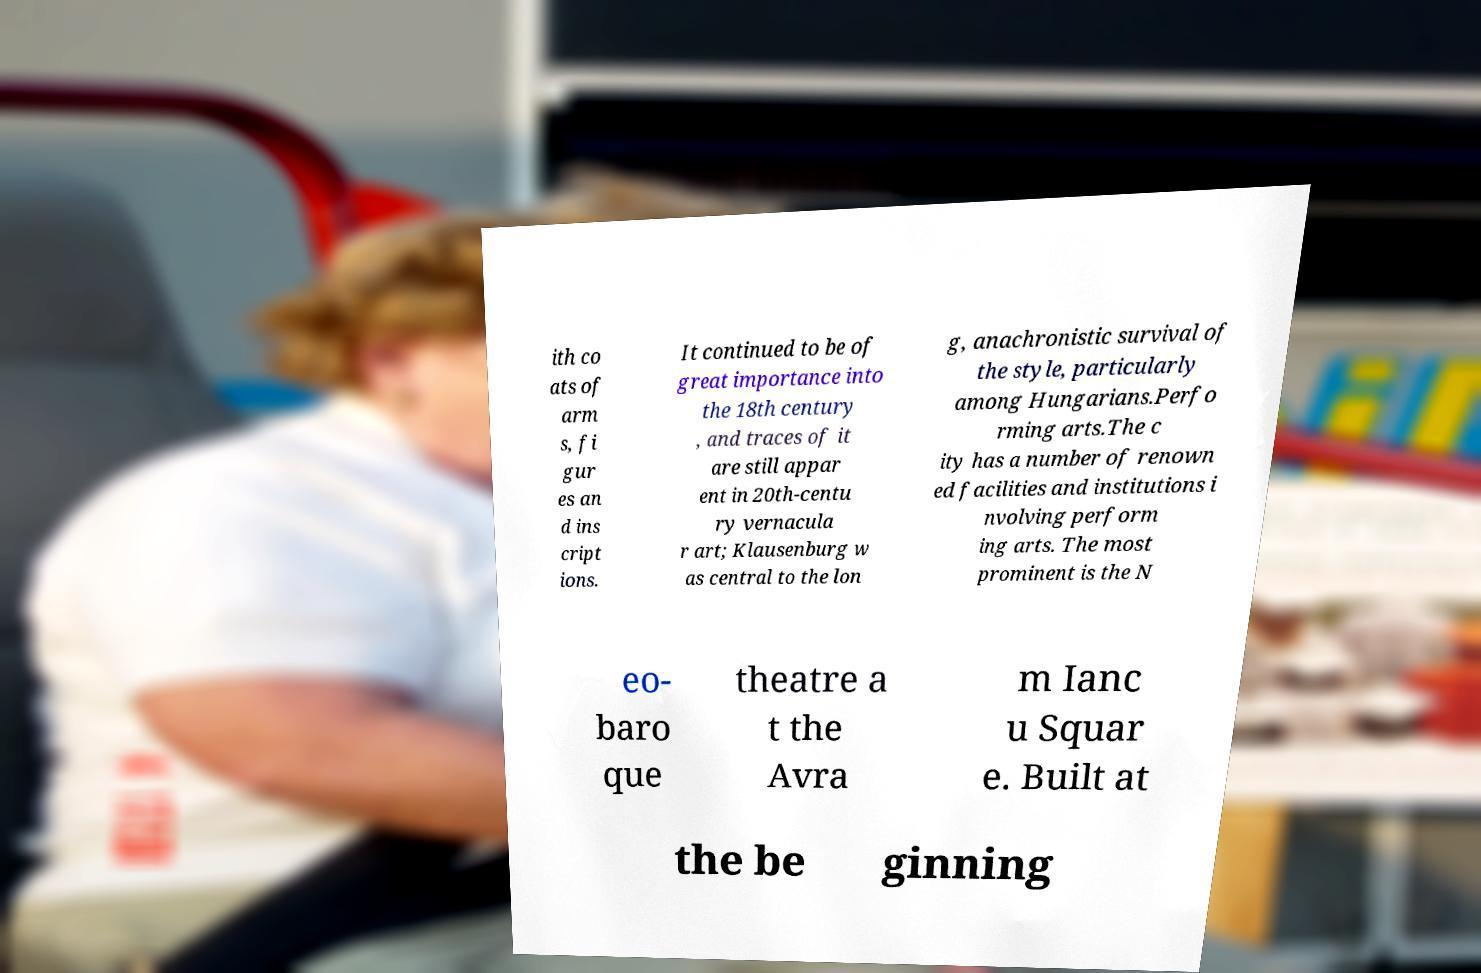Can you read and provide the text displayed in the image?This photo seems to have some interesting text. Can you extract and type it out for me? ith co ats of arm s, fi gur es an d ins cript ions. It continued to be of great importance into the 18th century , and traces of it are still appar ent in 20th-centu ry vernacula r art; Klausenburg w as central to the lon g, anachronistic survival of the style, particularly among Hungarians.Perfo rming arts.The c ity has a number of renown ed facilities and institutions i nvolving perform ing arts. The most prominent is the N eo- baro que theatre a t the Avra m Ianc u Squar e. Built at the be ginning 